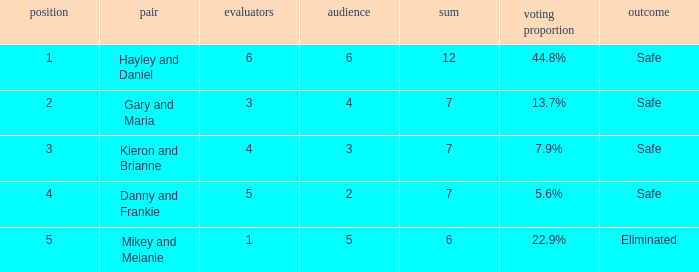How many public is there for the couple that got eliminated? 5.0. 